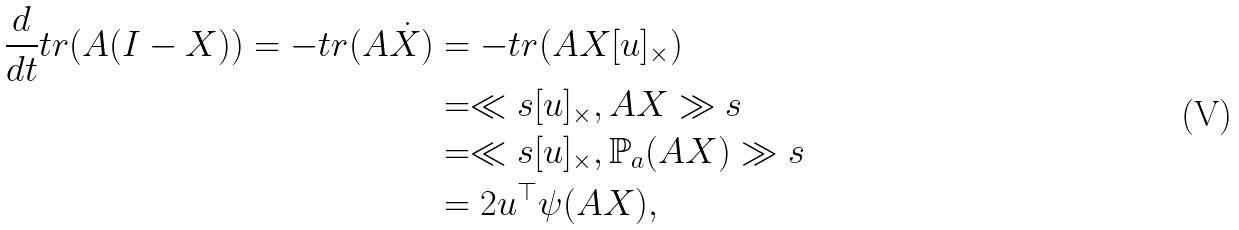<formula> <loc_0><loc_0><loc_500><loc_500>\frac { d } { d t } t r ( A ( I - X ) ) = - t r ( A \dot { X } ) & = - t r ( A X [ u ] _ { \times } ) \\ & = \ll s [ u ] _ { \times } , A X \gg s \\ & = \ll s [ u ] _ { \times } , \mathbb { P } _ { a } ( A X ) \gg s \\ & = 2 u ^ { \top } \psi ( A X ) ,</formula> 